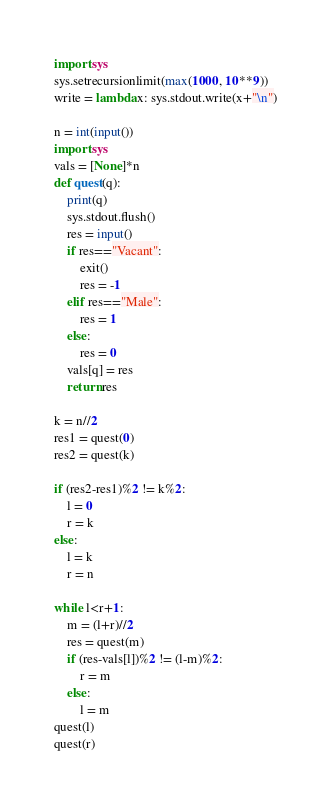Convert code to text. <code><loc_0><loc_0><loc_500><loc_500><_Python_>import sys
sys.setrecursionlimit(max(1000, 10**9))
write = lambda x: sys.stdout.write(x+"\n")

n = int(input())
import sys
vals = [None]*n
def quest(q):
    print(q)
    sys.stdout.flush()
    res = input()
    if res=="Vacant":
        exit()
        res = -1
    elif res=="Male":
        res = 1
    else:
        res = 0
    vals[q] = res
    return res

k = n//2
res1 = quest(0)
res2 = quest(k)

if (res2-res1)%2 != k%2:
    l = 0
    r = k
else:
    l = k
    r = n
    
while l<r+1:
    m = (l+r)//2
    res = quest(m)
    if (res-vals[l])%2 != (l-m)%2:
        r = m
    else:
        l = m
quest(l)
quest(r)</code> 